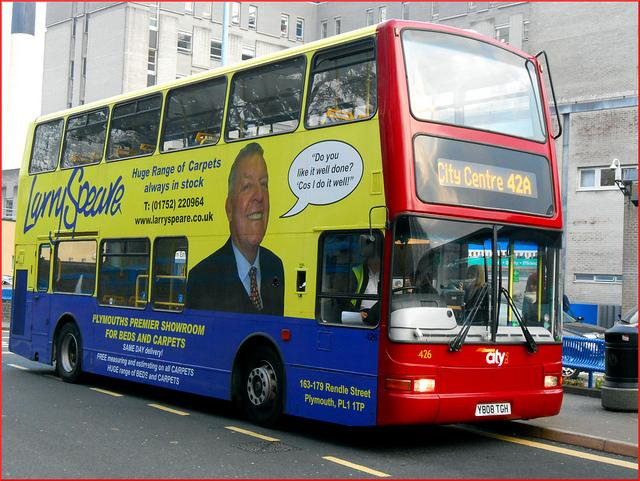What brand of bus manufacturer is displayed on the bus? city 